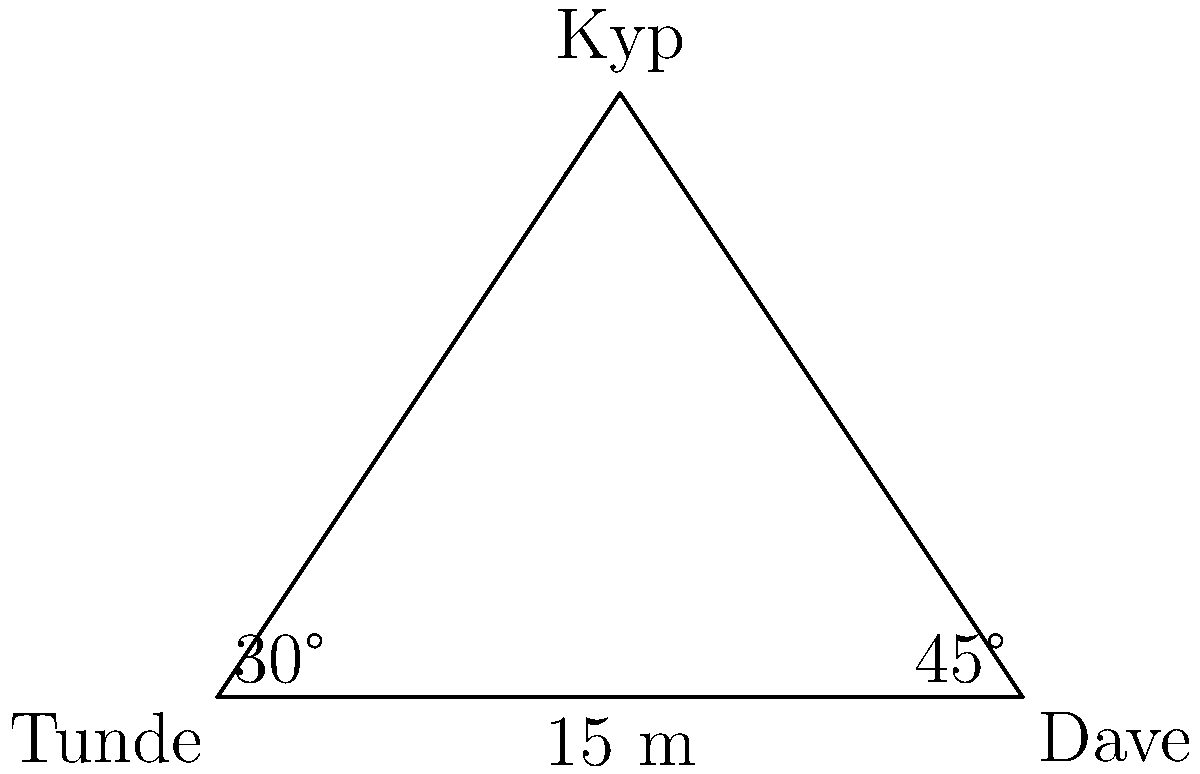During a TV On The Radio concert, band members Tunde, Dave, and Kyp are positioned on stage forming a triangle. Tunde and Dave are 15 meters apart on the front of the stage. Kyp is positioned behind them, forming a 30° angle with Tunde and a 45° angle with Dave. Using trigonometric ratios, calculate the distance between Tunde and Kyp to the nearest meter. Let's approach this step-by-step:

1) We can split the triangle into two right triangles by drawing a line from Kyp perpendicular to the line between Tunde and Dave.

2) Let's focus on the right triangle formed by Tunde, Kyp, and this perpendicular line.

3) In this right triangle, we know one angle (30°) and the length of the adjacent side (half of the distance between Tunde and Dave, which is 7.5 m).

4) We can use the tangent ratio to find the distance between Tunde and Kyp:

   $$\tan(30°) = \frac{\text{opposite}}{\text{adjacent}}$$

   $$\tan(30°) = \frac{\text{Kyp's distance behind stage}}{7.5\text{ m}}$$

5) We know that $\tan(30°) = \frac{1}{\sqrt{3}} \approx 0.577$

6) Substituting this:

   $$0.577 = \frac{\text{Kyp's distance behind stage}}{7.5\text{ m}}$$

7) Solving for Kyp's distance behind the stage:

   $$\text{Kyp's distance behind stage} = 7.5\text{ m} \times 0.577 \approx 4.33\text{ m}$$

8) Now we have a right triangle where we know both the base (7.5 m) and the height (4.33 m).

9) We can use the Pythagorean theorem to find the distance between Tunde and Kyp:

   $$\text{Distance}^2 = 7.5^2 + 4.33^2$$

10) Solving this:

    $$\text{Distance} = \sqrt{7.5^2 + 4.33^2} \approx 8.65\text{ m}$$

11) Rounding to the nearest meter as requested in the question, we get 9 meters.
Answer: 9 meters 